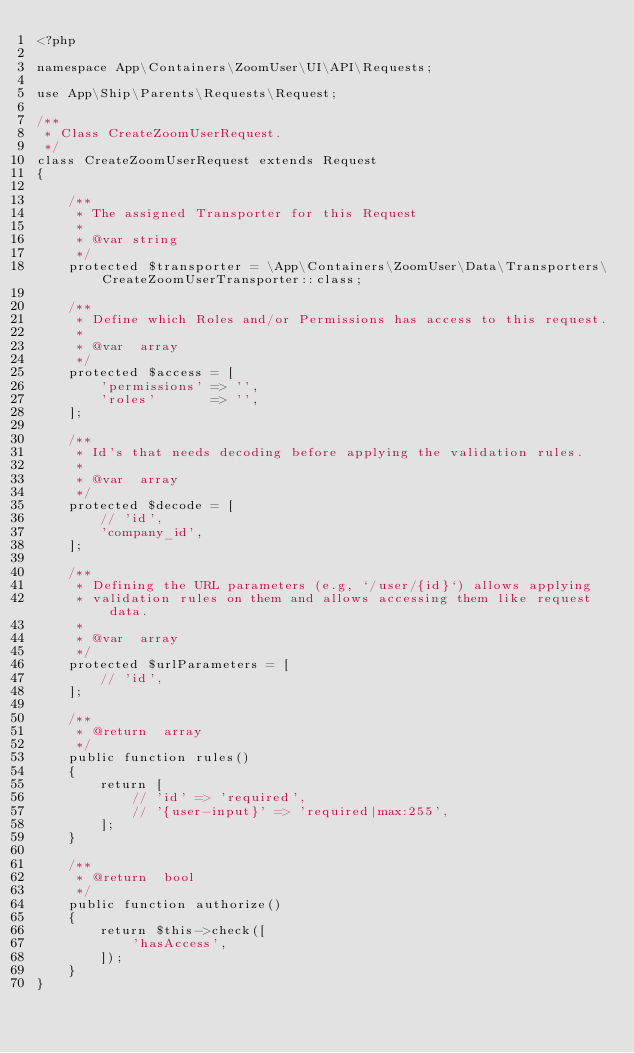Convert code to text. <code><loc_0><loc_0><loc_500><loc_500><_PHP_><?php

namespace App\Containers\ZoomUser\UI\API\Requests;

use App\Ship\Parents\Requests\Request;

/**
 * Class CreateZoomUserRequest.
 */
class CreateZoomUserRequest extends Request
{

    /**
     * The assigned Transporter for this Request
     *
     * @var string
     */
    protected $transporter = \App\Containers\ZoomUser\Data\Transporters\CreateZoomUserTransporter::class;

    /**
     * Define which Roles and/or Permissions has access to this request.
     *
     * @var  array
     */
    protected $access = [
        'permissions' => '',
        'roles'       => '',
    ];

    /**
     * Id's that needs decoding before applying the validation rules.
     *
     * @var  array
     */
    protected $decode = [
        // 'id',
        'company_id',
    ];

    /**
     * Defining the URL parameters (e.g, `/user/{id}`) allows applying
     * validation rules on them and allows accessing them like request data.
     *
     * @var  array
     */
    protected $urlParameters = [
        // 'id',
    ];

    /**
     * @return  array
     */
    public function rules()
    {
        return [
            // 'id' => 'required',
            // '{user-input}' => 'required|max:255',
        ];
    }

    /**
     * @return  bool
     */
    public function authorize()
    {
        return $this->check([
            'hasAccess',
        ]);
    }
}
</code> 